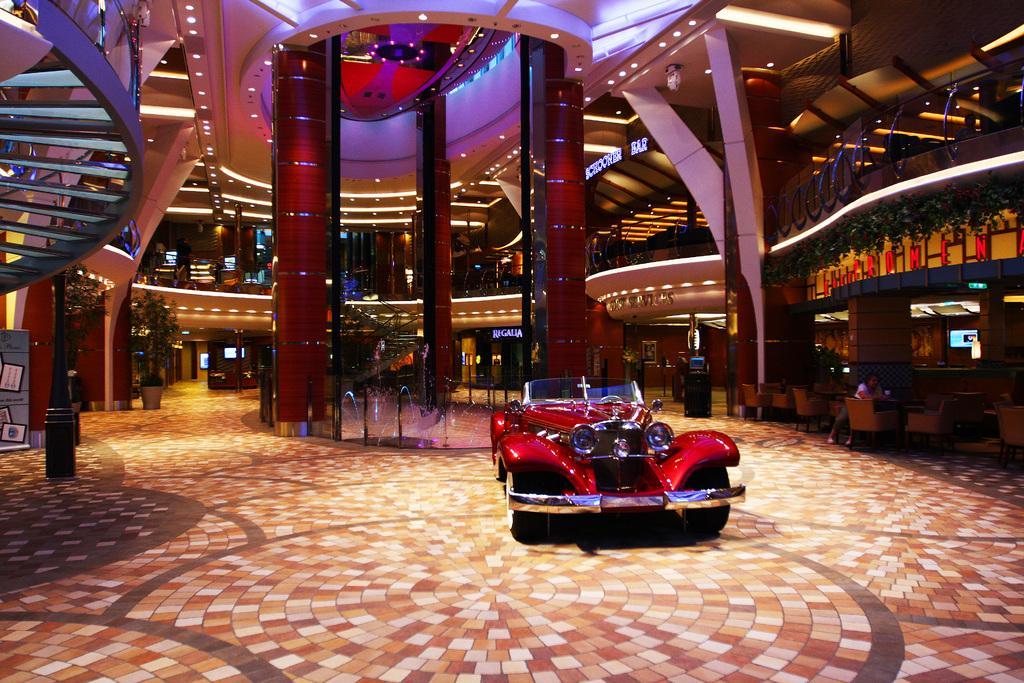How would you summarize this image in a sentence or two? As we can see in the image there is red color car, water and wall. There are stairs, lights, screens, plants and tiles. 